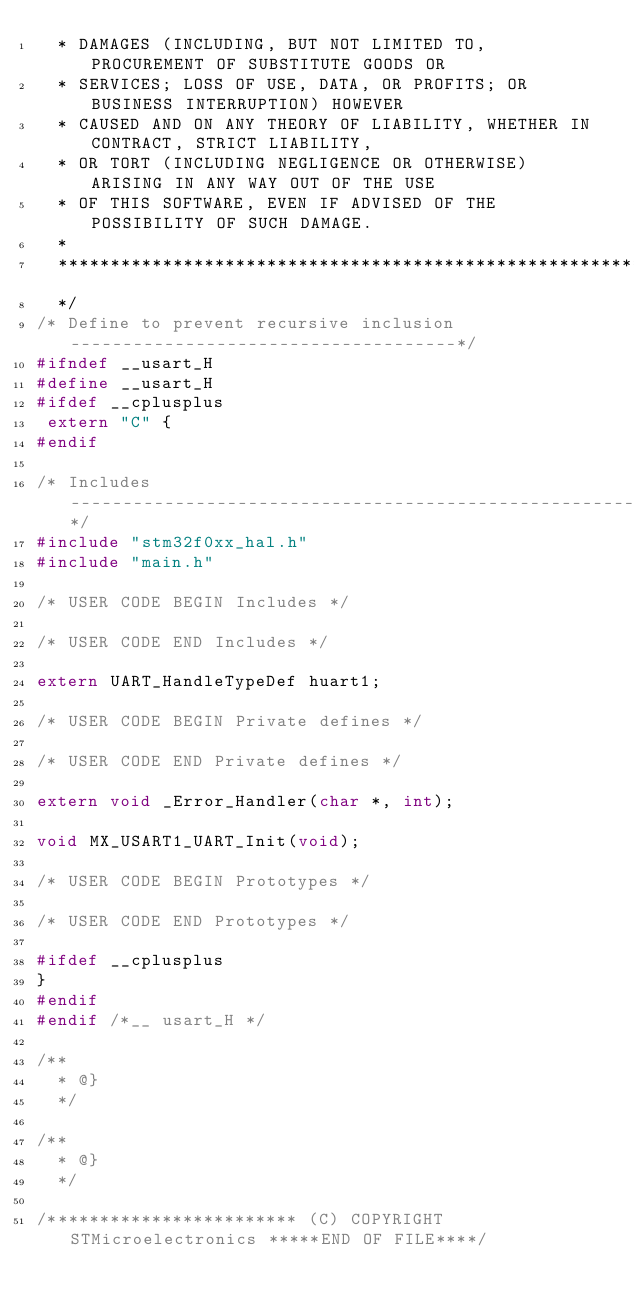<code> <loc_0><loc_0><loc_500><loc_500><_C_>  * DAMAGES (INCLUDING, BUT NOT LIMITED TO, PROCUREMENT OF SUBSTITUTE GOODS OR
  * SERVICES; LOSS OF USE, DATA, OR PROFITS; OR BUSINESS INTERRUPTION) HOWEVER
  * CAUSED AND ON ANY THEORY OF LIABILITY, WHETHER IN CONTRACT, STRICT LIABILITY,
  * OR TORT (INCLUDING NEGLIGENCE OR OTHERWISE) ARISING IN ANY WAY OUT OF THE USE
  * OF THIS SOFTWARE, EVEN IF ADVISED OF THE POSSIBILITY OF SUCH DAMAGE.
  *
  ******************************************************************************
  */
/* Define to prevent recursive inclusion -------------------------------------*/
#ifndef __usart_H
#define __usart_H
#ifdef __cplusplus
 extern "C" {
#endif

/* Includes ------------------------------------------------------------------*/
#include "stm32f0xx_hal.h"
#include "main.h"

/* USER CODE BEGIN Includes */

/* USER CODE END Includes */

extern UART_HandleTypeDef huart1;

/* USER CODE BEGIN Private defines */

/* USER CODE END Private defines */

extern void _Error_Handler(char *, int);

void MX_USART1_UART_Init(void);

/* USER CODE BEGIN Prototypes */

/* USER CODE END Prototypes */

#ifdef __cplusplus
}
#endif
#endif /*__ usart_H */

/**
  * @}
  */

/**
  * @}
  */

/************************ (C) COPYRIGHT STMicroelectronics *****END OF FILE****/
</code> 